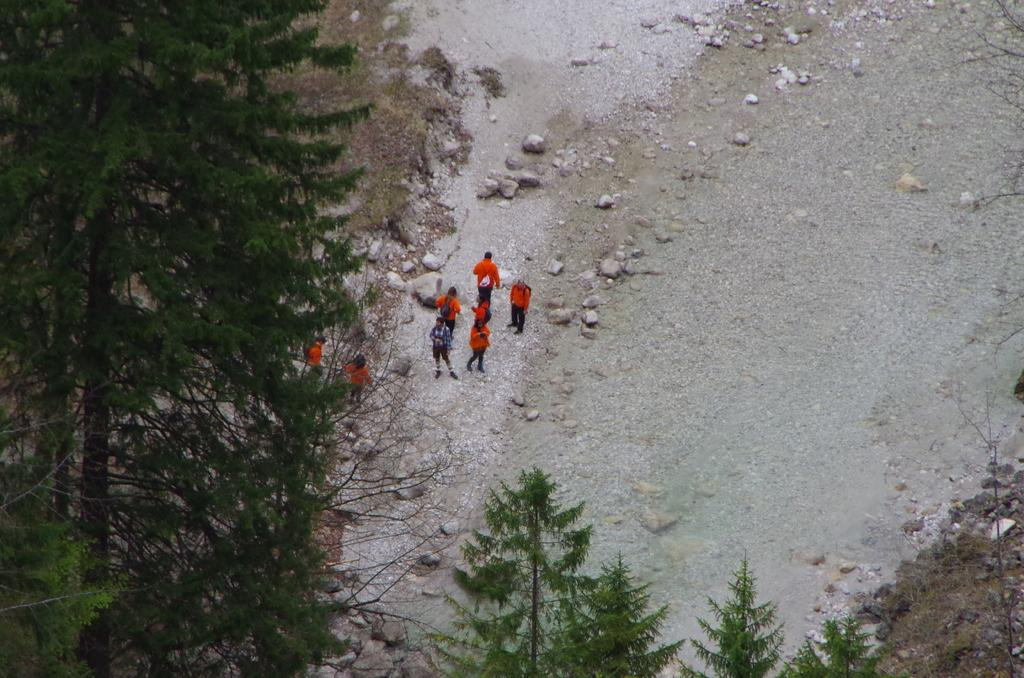What type of vegetation is present on the left side of the image? There are trees on the left side of the image. Where are the trees also located in the image? The trees are also at the bottom of the image. What can be seen in the middle of the image? There are people and rocks in the middle of the image. What type of crack is visible in the image? There is no crack present in the image. How much dust can be seen on the rocks in the image? There is no dust visible on the rocks in the image. 